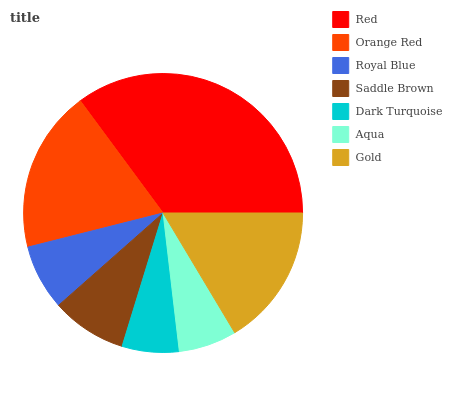Is Dark Turquoise the minimum?
Answer yes or no. Yes. Is Red the maximum?
Answer yes or no. Yes. Is Orange Red the minimum?
Answer yes or no. No. Is Orange Red the maximum?
Answer yes or no. No. Is Red greater than Orange Red?
Answer yes or no. Yes. Is Orange Red less than Red?
Answer yes or no. Yes. Is Orange Red greater than Red?
Answer yes or no. No. Is Red less than Orange Red?
Answer yes or no. No. Is Saddle Brown the high median?
Answer yes or no. Yes. Is Saddle Brown the low median?
Answer yes or no. Yes. Is Orange Red the high median?
Answer yes or no. No. Is Gold the low median?
Answer yes or no. No. 